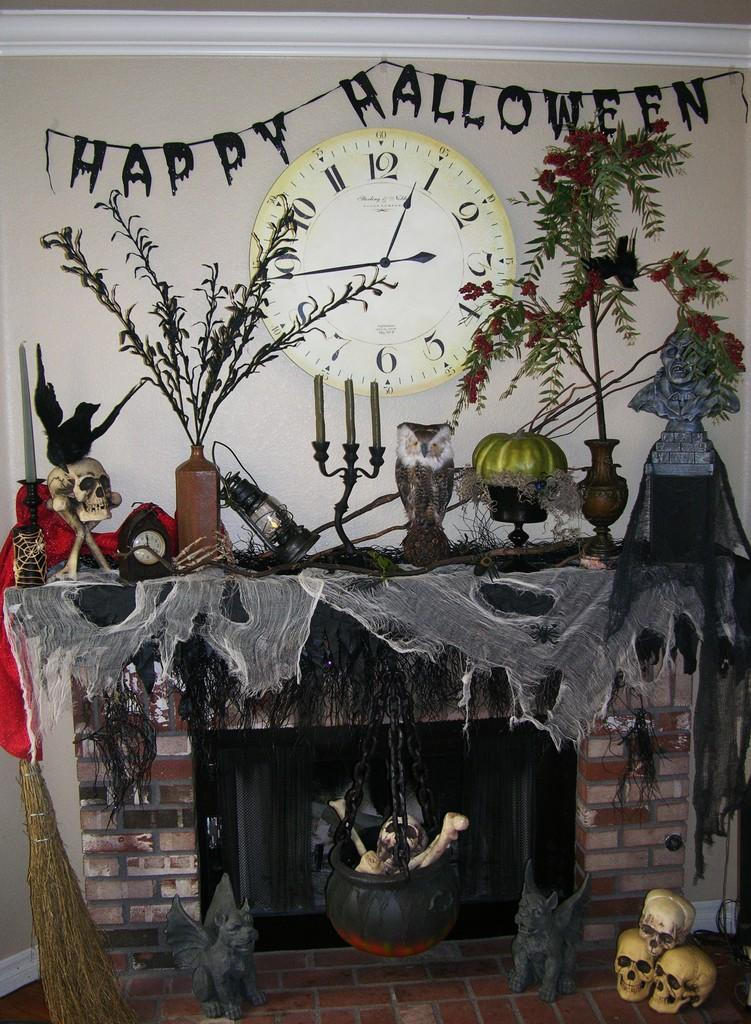<image>
Provide a brief description of the given image. A fireplace decorated for halloween including a sign that says halloween. 